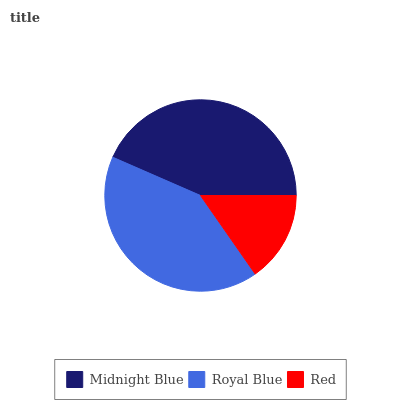Is Red the minimum?
Answer yes or no. Yes. Is Midnight Blue the maximum?
Answer yes or no. Yes. Is Royal Blue the minimum?
Answer yes or no. No. Is Royal Blue the maximum?
Answer yes or no. No. Is Midnight Blue greater than Royal Blue?
Answer yes or no. Yes. Is Royal Blue less than Midnight Blue?
Answer yes or no. Yes. Is Royal Blue greater than Midnight Blue?
Answer yes or no. No. Is Midnight Blue less than Royal Blue?
Answer yes or no. No. Is Royal Blue the high median?
Answer yes or no. Yes. Is Royal Blue the low median?
Answer yes or no. Yes. Is Midnight Blue the high median?
Answer yes or no. No. Is Midnight Blue the low median?
Answer yes or no. No. 